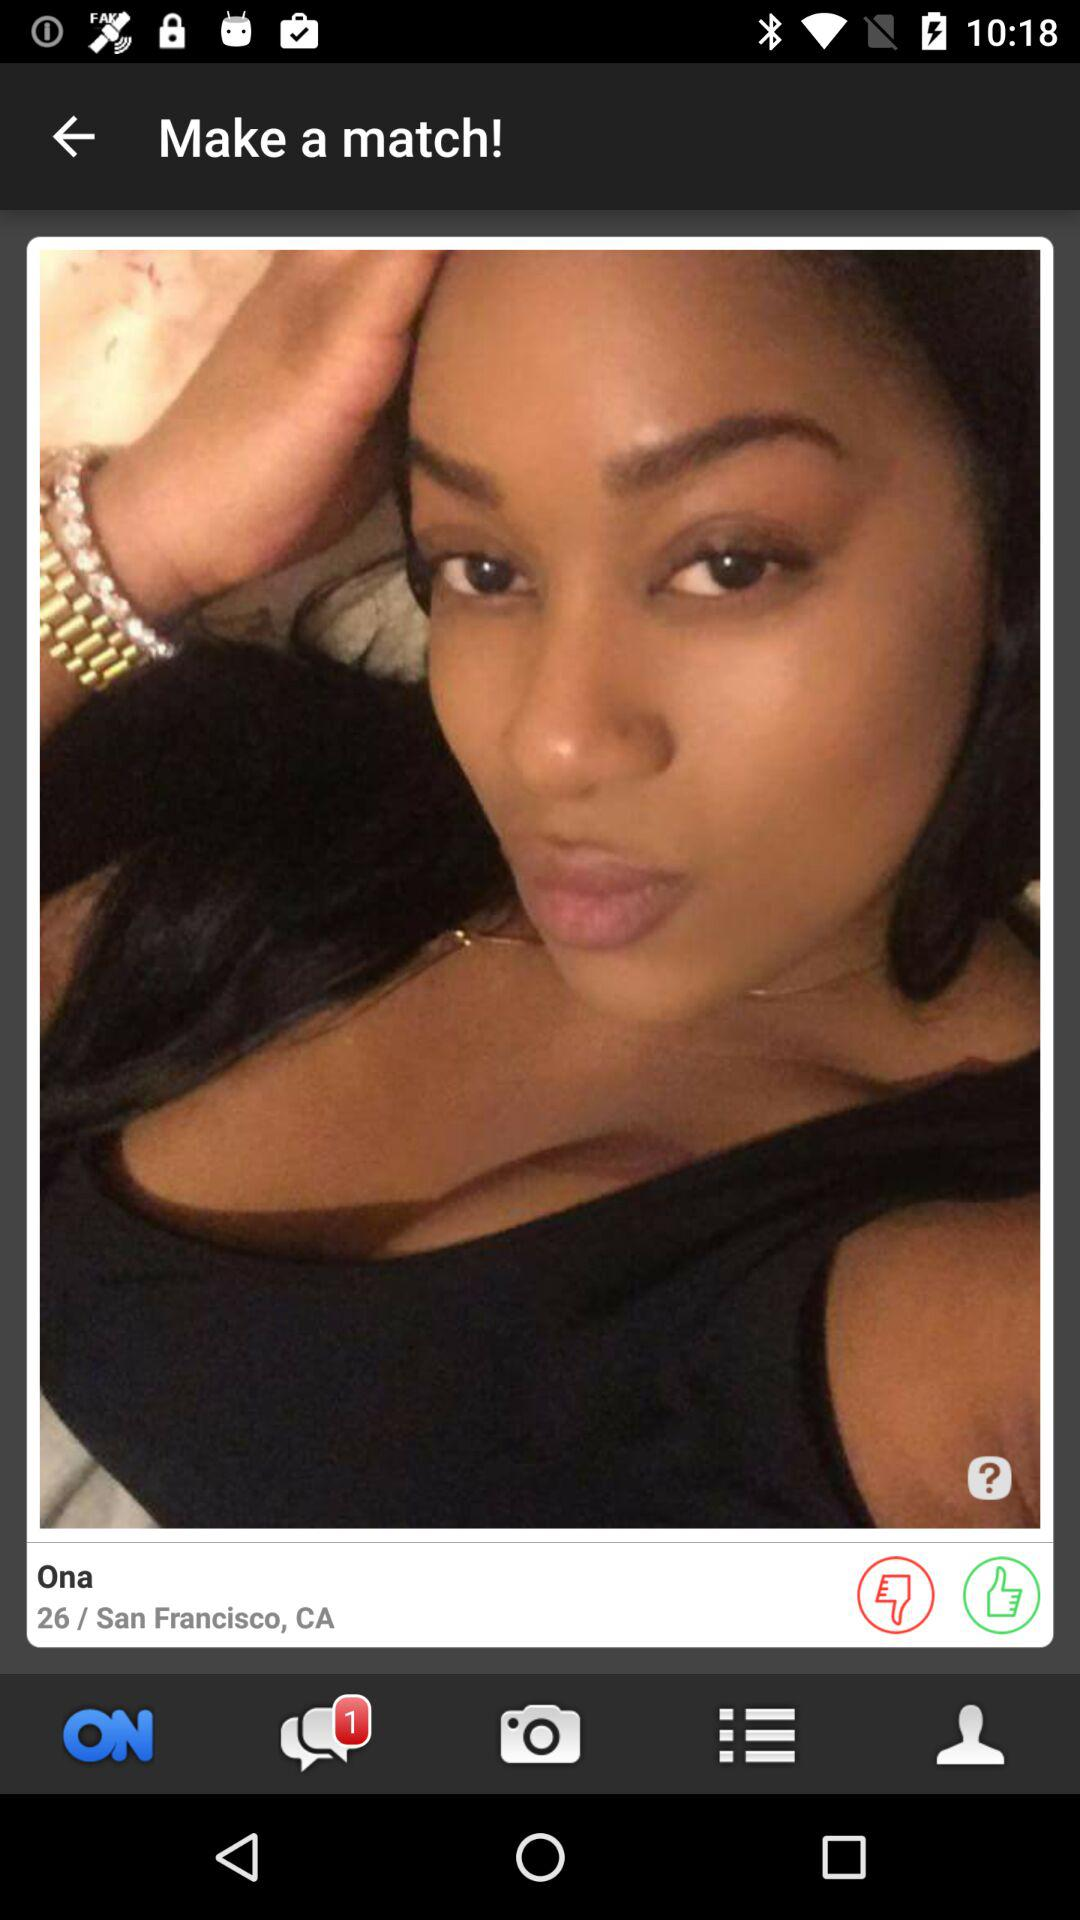How many likes does Ona have?
When the provided information is insufficient, respond with <no answer>. <no answer> 